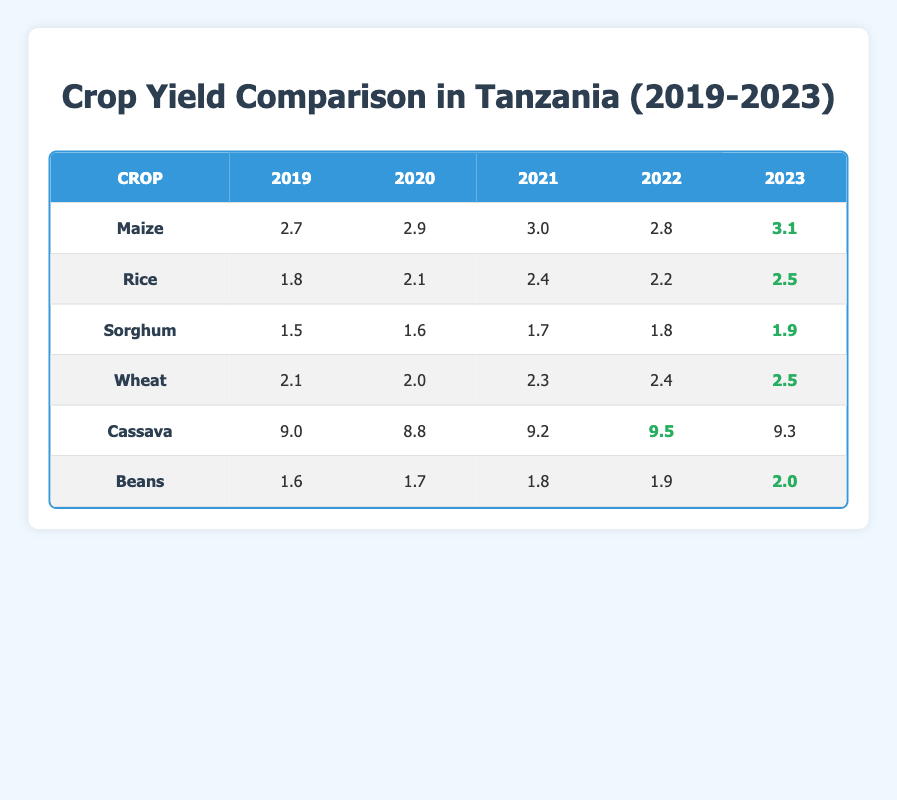What was the yield of Maize in 2022? The yield of Maize in 2022, as shown in the table, is listed under the corresponding year column. Looking at the row for Maize, the yield for the year 2022 is 2.8
Answer: 2.8 Which crop had the highest yield in 2023? In the table, we look at the column for 2023 and compare all the crops' yields. The crop with the highest yield in 2023 is Cassava, with a yield of 9.3
Answer: Cassava What is the average yield of Rice over the last five years? To find the average yield of Rice, we sum the yields from 2019 to 2023: (1.8 + 2.1 + 2.4 + 2.2 + 2.5) = 10.0. Then, we divide by the number of years, which is 5: 10.0 / 5 = 2.0
Answer: 2.0 Was the yield of Wheat greater in 2022 than in 2021? We check the yields for Wheat in both years in the table. The yield in 2021 is 2.3, while in 2022, it is 2.4. Since 2.4 is greater than 2.3, the statement is true
Answer: Yes Which crop showed the greatest increase in yield from 2019 to 2023? We evaluate the differences in yields from 2019 to 2023 for each crop. For Maize, the increase is 3.1 - 2.7 = 0.4; for Rice, it is 2.5 - 1.8 = 0.7; for Sorghum, it is 1.9 - 1.5 = 0.4; for Wheat, it is 2.5 - 2.1 = 0.4; for Cassava, it is 9.3 - 9.0 = 0.3; and for Beans, it is 2.0 - 1.6 = 0.4. The greatest increase is in Rice, with an increase of 0.7
Answer: Rice What was the yield of Beans in 2021? The yield of Beans in 2021 is found by looking at the corresponding row and column in the table. For Beans in 2021, the yield is 1.8
Answer: 1.8 Is it true that Cassava had the highest yield in all five years? We examine the table for yields of Cassava across all five years. The values are 9.0, 8.8, 9.2, 9.5, and 9.3. Although Cassava has the highest yield compared to others, we must check if it had the highest yield in each year. In 2019, the yield is higher than all crops. However, in 2020 and onwards, other crops did not exceed the Cassava yield of 9.5 in 2022. Therefore, it's false that it had the highest in all five years since Maize and other crops had lower yields
Answer: No What is the difference in yield between Sorghum in 2023 and Maize in 2020? To find the difference, we take the yield of Sorghum in 2023, which is 1.9, and subtract the yield of Maize in 2020, which is 2.9. Performing the calculation, we have 1.9 - 2.9 = -1.0. The negative value indicates that Sorghum has a lower yield than Maize for these years
Answer: -1.0 Which crop had the lowest yield in 2021? We compare the yields presented for each crop in 2021. The yields are Maize (3.0), Rice (2.4), Sorghum (1.7), Wheat (2.3), Cassava (9.2), and Beans (1.8). The lowest yield in 2021 is Sorghum with 1.7
Answer: Sorghum What was the yield trend for Beans from 2019 to 2023? We analyze the yields of Beans across the years: 1.6 (2019), 1.7 (2020), 1.8 (2021), 1.9 (2022), and 2.0 (2023). The values show a steady increase in yield each year, suggesting an upward trend over the five years
Answer: Upward trend 